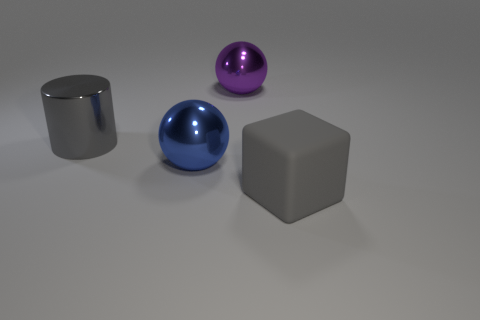Is the number of small green metal balls greater than the number of large purple things?
Provide a succinct answer. No. How many large objects are both behind the gray block and in front of the large purple sphere?
Offer a terse response. 2. There is a large gray thing that is to the right of the blue ball; how many large gray cylinders are in front of it?
Give a very brief answer. 0. There is a gray thing to the left of the big purple ball; is it the same size as the sphere in front of the purple ball?
Your answer should be very brief. Yes. What number of green metallic blocks are there?
Your answer should be very brief. 0. How many large brown objects are made of the same material as the large purple sphere?
Your answer should be very brief. 0. Is the number of gray matte blocks that are left of the large purple metallic thing the same as the number of large cylinders?
Offer a terse response. No. There is a large cylinder that is the same color as the rubber thing; what material is it?
Ensure brevity in your answer.  Metal. There is a purple metallic sphere; is it the same size as the sphere in front of the metallic cylinder?
Offer a very short reply. Yes. How many other things are the same size as the gray metal cylinder?
Provide a short and direct response. 3. 